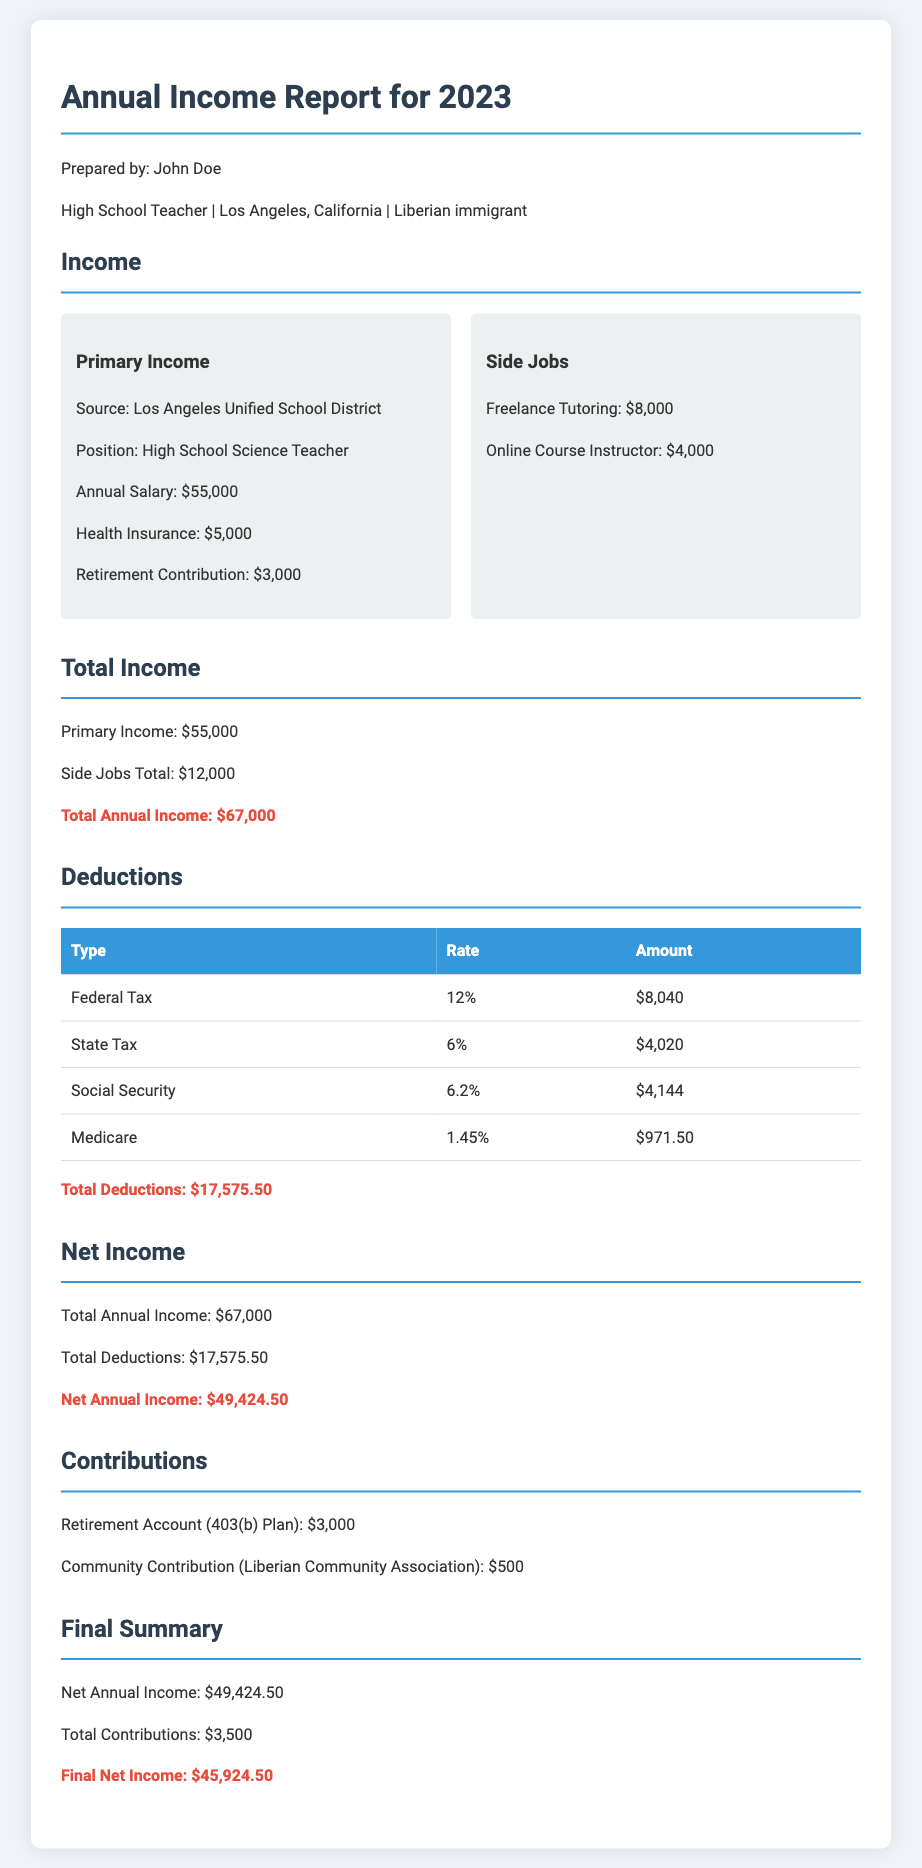What is the total annual income? The total annual income is stated as the sum of primary income and side jobs, which is $55,000 + $12,000 = $67,000.
Answer: $67,000 What is the annual salary from the primary income? The annual salary from the primary income is specifically mentioned under the primary income section.
Answer: $55,000 How much was deducted for federal tax? The amount deducted for federal tax is listed in the deductions table.
Answer: $8,040 What is the total amount for side jobs? The total from side jobs is the sum of the freelance tutoring and online course instructor earnings.
Answer: $12,000 What is the net annual income after deductions? The net annual income is calculated by subtracting total deductions from total annual income.
Answer: $49,424.50 What percentage is the state tax deduction? The state tax deduction rate is provided in the deductions table.
Answer: 6% What is the amount contributed to the retirement account? The contribution amount for the retirement account is specified in the contributions section.
Answer: $3,000 What is the final net income after contributions? The final net income is the net annual income minus total contributions, provided in the final summary.
Answer: $45,924.50 Who prepared the annual income report? The name of the person who prepared the report can be found at the top of the document.
Answer: John Doe 